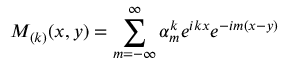<formula> <loc_0><loc_0><loc_500><loc_500>M _ { ( k ) } ( x , y ) = \sum _ { m = - \infty } ^ { \infty } \alpha _ { m } ^ { k } e ^ { i k x } e ^ { - i m ( x - y ) }</formula> 